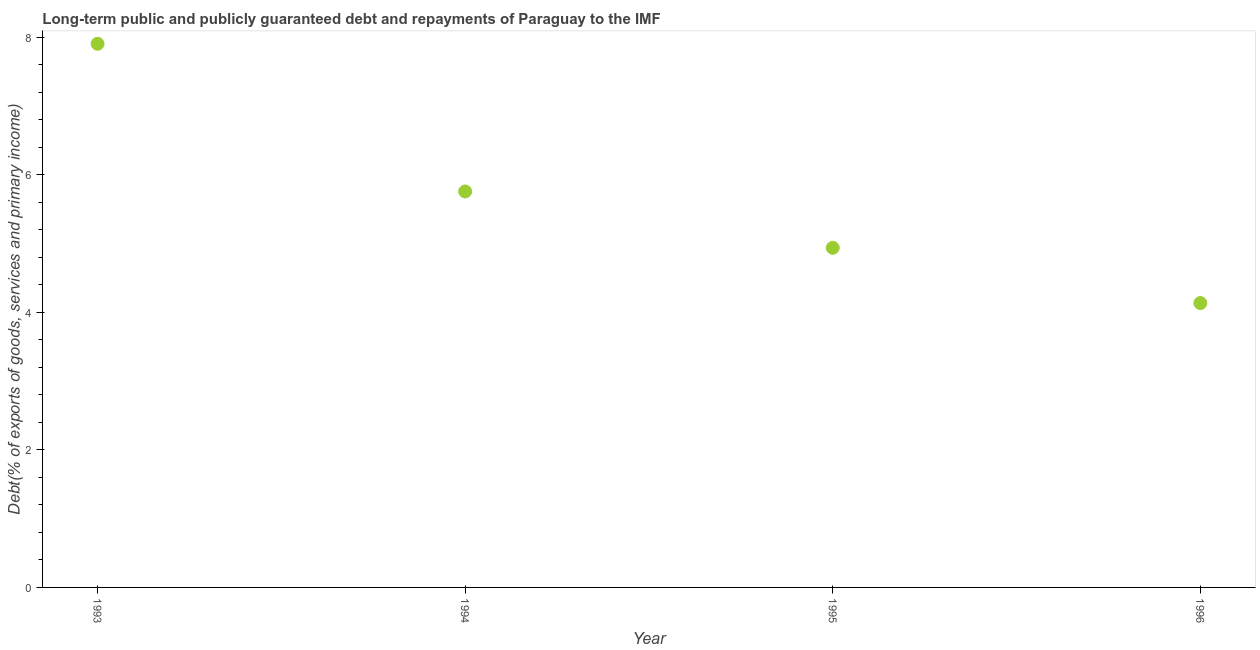What is the debt service in 1995?
Make the answer very short. 4.94. Across all years, what is the maximum debt service?
Offer a terse response. 7.9. Across all years, what is the minimum debt service?
Offer a terse response. 4.13. In which year was the debt service maximum?
Your response must be concise. 1993. In which year was the debt service minimum?
Provide a short and direct response. 1996. What is the sum of the debt service?
Offer a terse response. 22.73. What is the difference between the debt service in 1993 and 1995?
Keep it short and to the point. 2.97. What is the average debt service per year?
Provide a succinct answer. 5.68. What is the median debt service?
Your answer should be very brief. 5.35. Do a majority of the years between 1993 and 1994 (inclusive) have debt service greater than 4.4 %?
Ensure brevity in your answer.  Yes. What is the ratio of the debt service in 1993 to that in 1994?
Offer a terse response. 1.37. Is the debt service in 1993 less than that in 1995?
Provide a short and direct response. No. Is the difference between the debt service in 1994 and 1996 greater than the difference between any two years?
Provide a short and direct response. No. What is the difference between the highest and the second highest debt service?
Your answer should be compact. 2.15. Is the sum of the debt service in 1994 and 1995 greater than the maximum debt service across all years?
Your answer should be compact. Yes. What is the difference between the highest and the lowest debt service?
Offer a very short reply. 3.77. In how many years, is the debt service greater than the average debt service taken over all years?
Keep it short and to the point. 2. Does the debt service monotonically increase over the years?
Your response must be concise. No. How many dotlines are there?
Offer a very short reply. 1. How many years are there in the graph?
Your answer should be very brief. 4. What is the difference between two consecutive major ticks on the Y-axis?
Your answer should be compact. 2. Are the values on the major ticks of Y-axis written in scientific E-notation?
Give a very brief answer. No. Does the graph contain any zero values?
Offer a very short reply. No. What is the title of the graph?
Provide a short and direct response. Long-term public and publicly guaranteed debt and repayments of Paraguay to the IMF. What is the label or title of the X-axis?
Your response must be concise. Year. What is the label or title of the Y-axis?
Ensure brevity in your answer.  Debt(% of exports of goods, services and primary income). What is the Debt(% of exports of goods, services and primary income) in 1993?
Make the answer very short. 7.9. What is the Debt(% of exports of goods, services and primary income) in 1994?
Offer a very short reply. 5.76. What is the Debt(% of exports of goods, services and primary income) in 1995?
Give a very brief answer. 4.94. What is the Debt(% of exports of goods, services and primary income) in 1996?
Give a very brief answer. 4.13. What is the difference between the Debt(% of exports of goods, services and primary income) in 1993 and 1994?
Ensure brevity in your answer.  2.15. What is the difference between the Debt(% of exports of goods, services and primary income) in 1993 and 1995?
Offer a very short reply. 2.97. What is the difference between the Debt(% of exports of goods, services and primary income) in 1993 and 1996?
Provide a succinct answer. 3.77. What is the difference between the Debt(% of exports of goods, services and primary income) in 1994 and 1995?
Offer a terse response. 0.82. What is the difference between the Debt(% of exports of goods, services and primary income) in 1994 and 1996?
Provide a short and direct response. 1.62. What is the difference between the Debt(% of exports of goods, services and primary income) in 1995 and 1996?
Your response must be concise. 0.8. What is the ratio of the Debt(% of exports of goods, services and primary income) in 1993 to that in 1994?
Your answer should be very brief. 1.37. What is the ratio of the Debt(% of exports of goods, services and primary income) in 1993 to that in 1995?
Provide a succinct answer. 1.6. What is the ratio of the Debt(% of exports of goods, services and primary income) in 1993 to that in 1996?
Your answer should be compact. 1.91. What is the ratio of the Debt(% of exports of goods, services and primary income) in 1994 to that in 1995?
Offer a very short reply. 1.17. What is the ratio of the Debt(% of exports of goods, services and primary income) in 1994 to that in 1996?
Your answer should be very brief. 1.39. What is the ratio of the Debt(% of exports of goods, services and primary income) in 1995 to that in 1996?
Your answer should be compact. 1.19. 